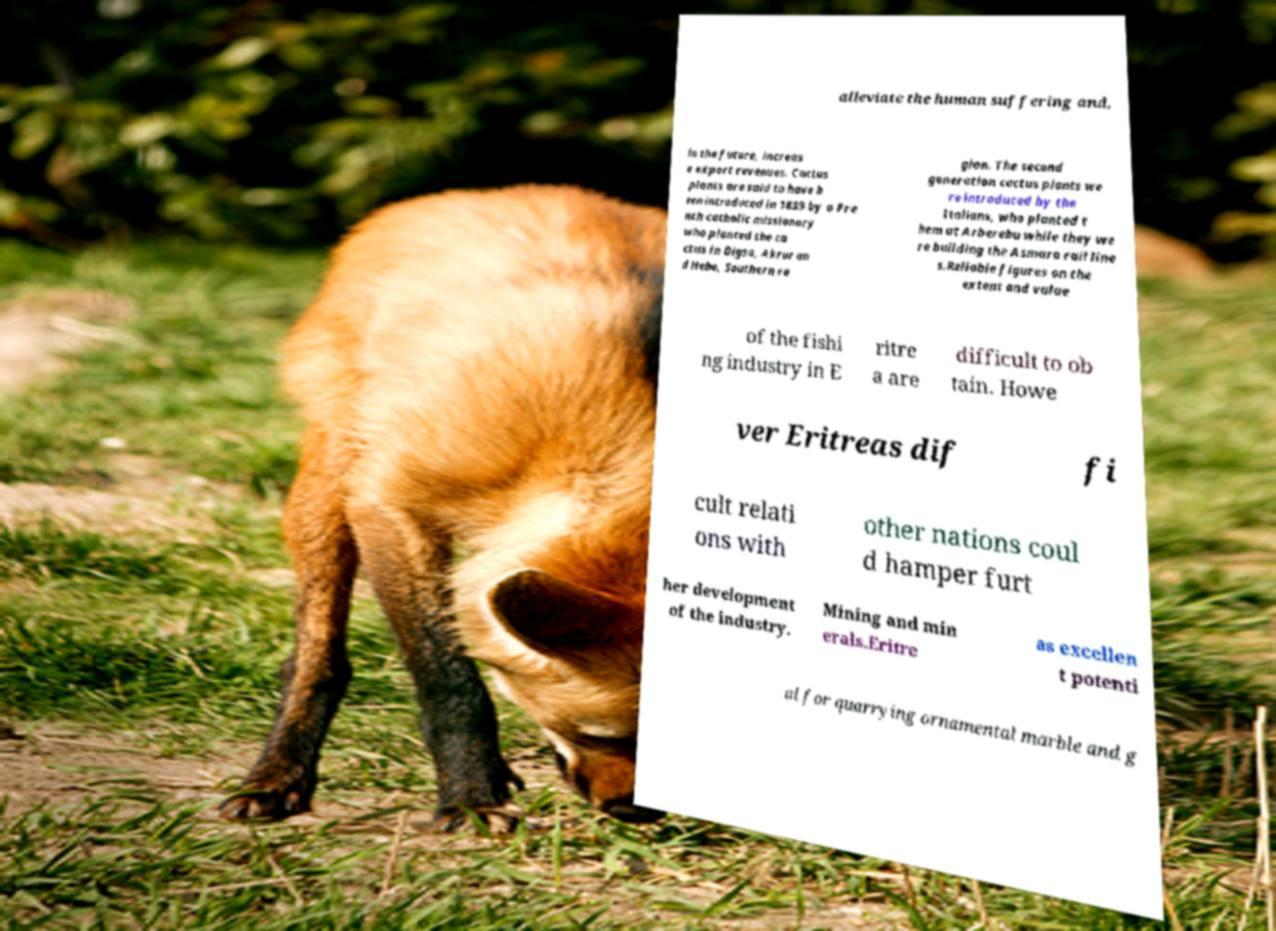I need the written content from this picture converted into text. Can you do that? alleviate the human suffering and, in the future, increas e export revenues. Cactus plants are said to have b een introduced in 1839 by a Fre nch catholic missionary who planted the ca ctus in Digsa, Akrur an d Hebo, Southern re gion. The second generation cactus plants we re introduced by the Italians, who planted t hem at Arberebu while they we re building the Asmara rail line s.Reliable figures on the extent and value of the fishi ng industry in E ritre a are difficult to ob tain. Howe ver Eritreas dif fi cult relati ons with other nations coul d hamper furt her development of the industry. Mining and min erals.Eritre as excellen t potenti al for quarrying ornamental marble and g 